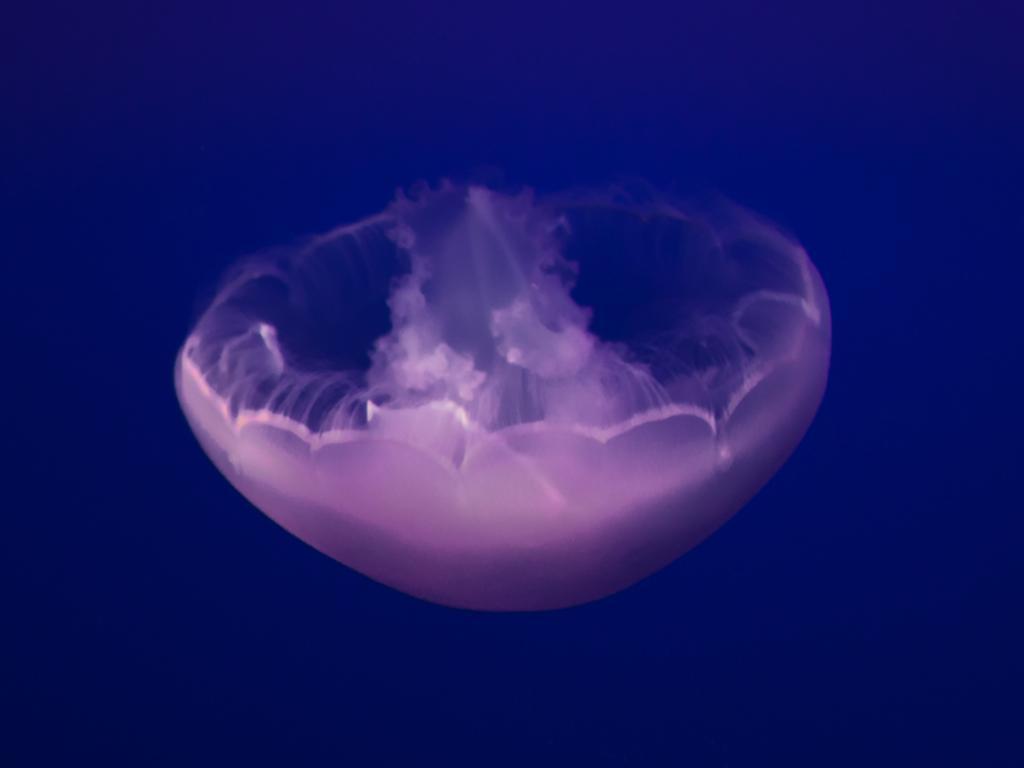Can you describe this image briefly? In this image a jellyfish in the center of the image. 